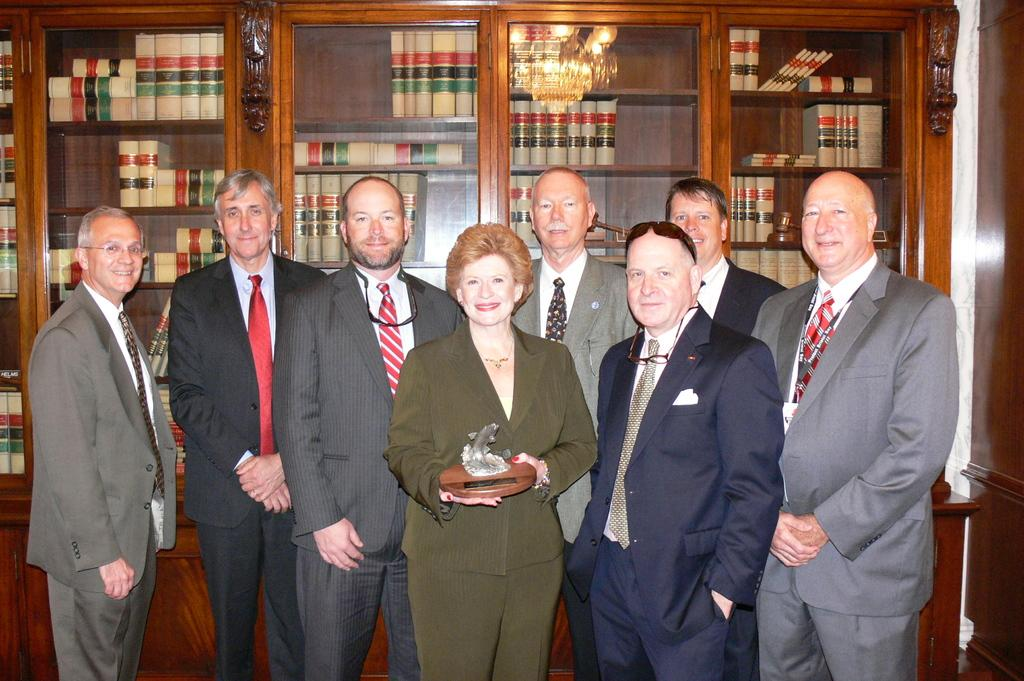What is happening in the image? There are people standing in the image. Can you describe what the woman is doing? A woman is holding an object in her hand. What can be seen in the background of the image? There are books on a shelf in the background of the image. How does the woman untie the knot with her mouth in the image? There is no knot or mouth action present in the image; the woman is simply holding an object in her hand. 